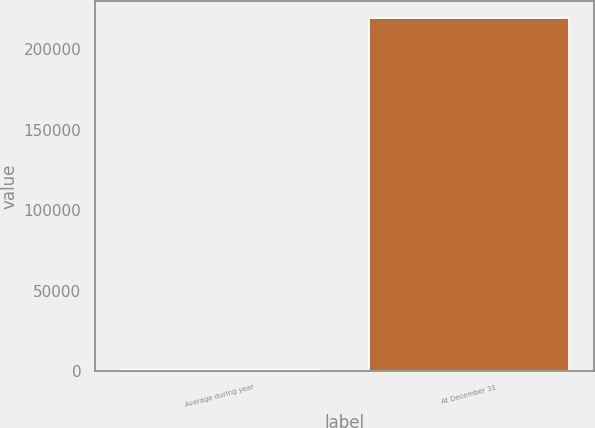Convert chart to OTSL. <chart><loc_0><loc_0><loc_500><loc_500><bar_chart><fcel>Average during year<fcel>At December 31<nl><fcel>351<fcel>219324<nl></chart> 